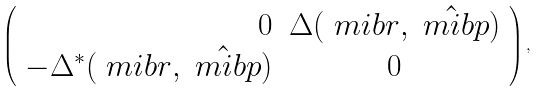Convert formula to latex. <formula><loc_0><loc_0><loc_500><loc_500>\left ( \begin{array} { r c } 0 & \Delta ( { \ m i b r } , \hat { \ m i b p } ) \\ - \Delta ^ { * } ( { \ m i b r } , \hat { \ m i b p } ) & 0 \end{array} \right ) ,</formula> 